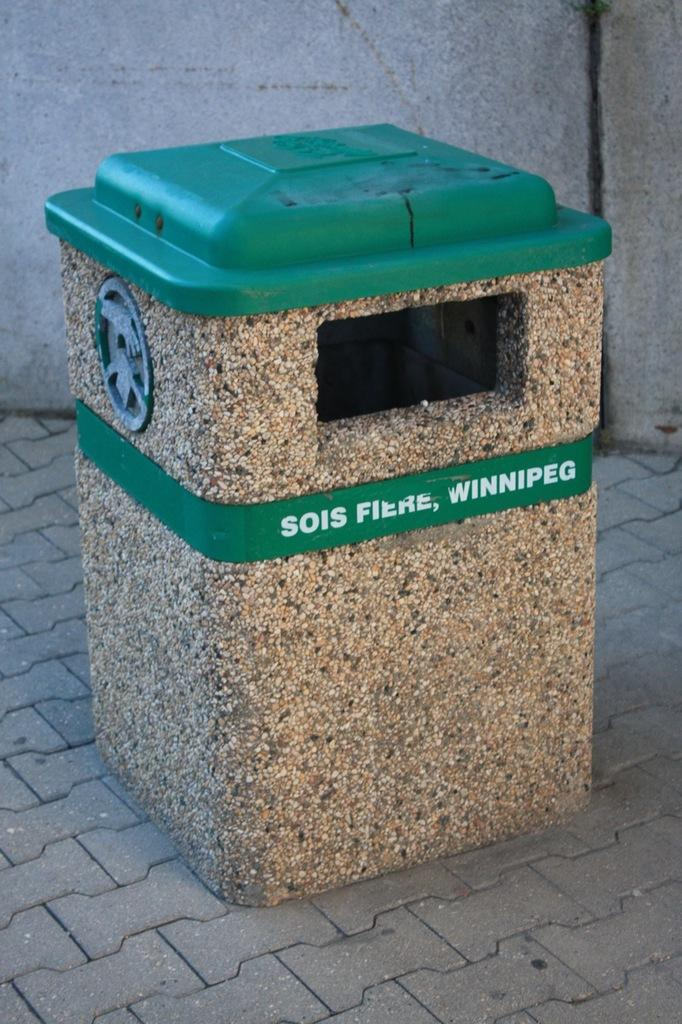<image>
Give a short and clear explanation of the subsequent image. A TRASH CAN WITH A GREEN LID AND LABEL THAT STATES "SOIS FIERE, WINNIPEG" 